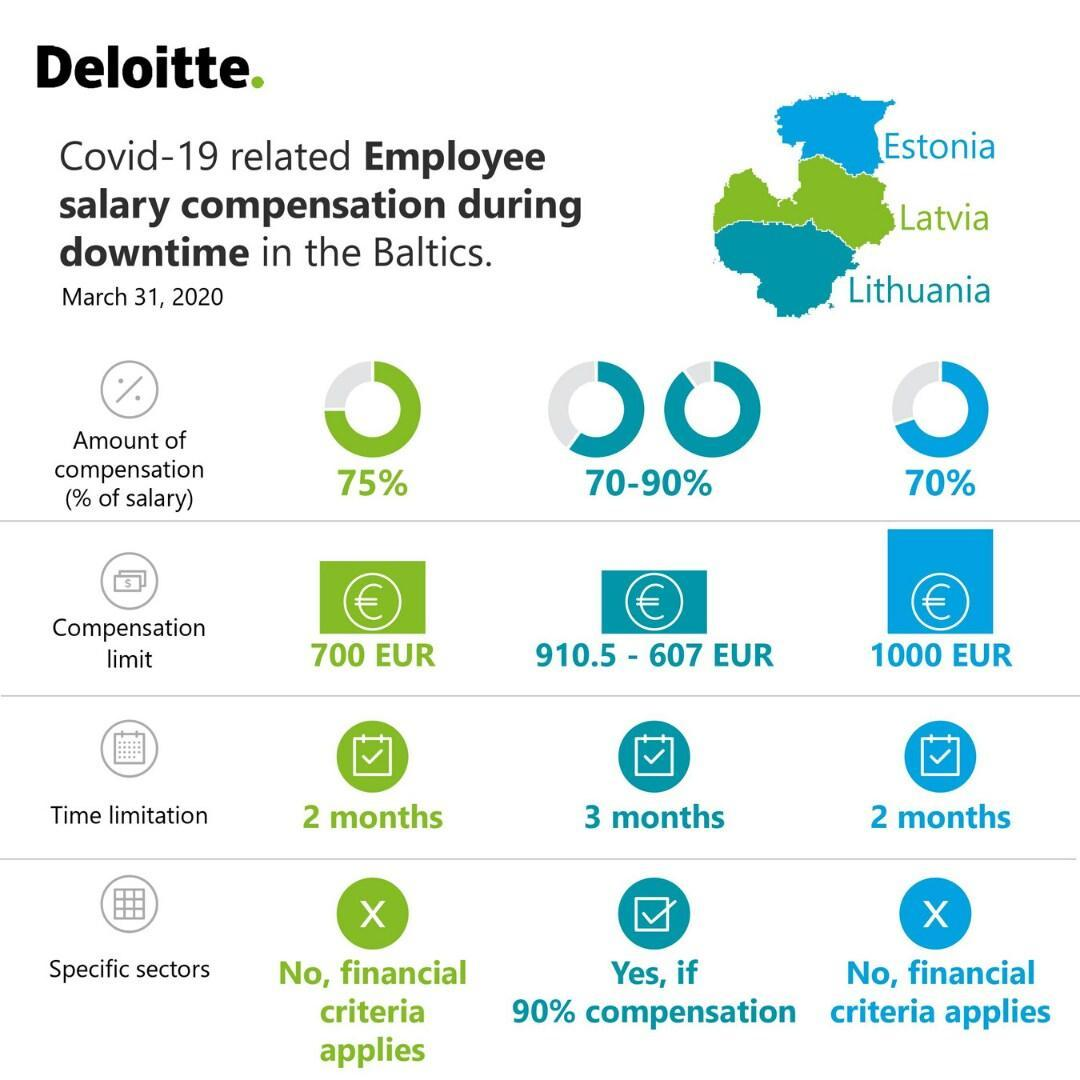What is the percentage of salary compensation offered to the employees due to the impact of COVID-19 pandemic in Estonia as of March 31, 2020?
Answer the question with a short phrase. 70% What is the time limit applied for the Covid-19 related employee salary compensation in Latvia as of March 31, 2020? 2 months What is the time limit applied for the Covid-19 related employee salary compensation in Lithuania as of March 31, 2020? 3 months What is the percentage of salary compensation offered to the employees due to the impact of COVID-19 pandemic in Lithuania as of March 31, 2020? 70-90% What is the percentage of salary compensation offered to the employees due to the impact of COVID-19 pandemic in Latvia as of March 31, 2020? 75% In which baltic states, no financial criteria is applied on specific sectors as of March 31, 2020? Latvia, Estonia What is the Covid-19 related salary compensation limit for the employees in Estonia as of March 31, 2020? 1000 EUR What is the Covid-19 related salary compensation limit for the employees in Lithuania as of March 31, 2020? 910.5 - 607 EUR In which baltic state, financial criteria is applied on specific sectors if 90% salary compensation is offered as of March 31, 2020? Lithuania 